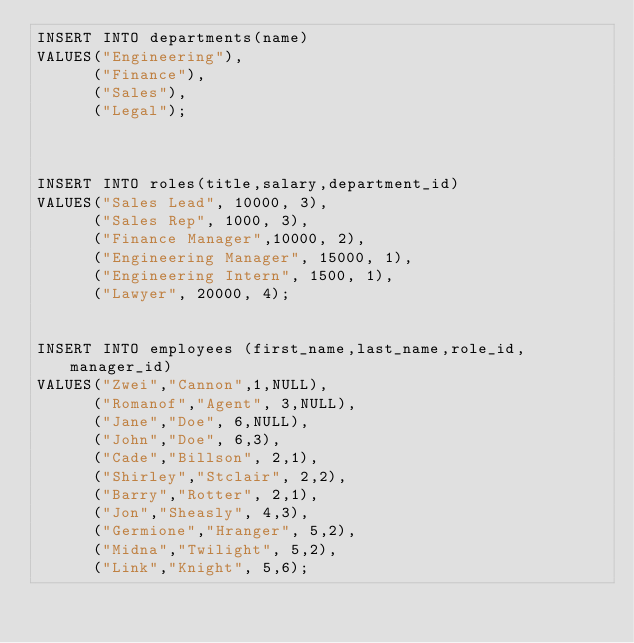Convert code to text. <code><loc_0><loc_0><loc_500><loc_500><_SQL_>INSERT INTO departments(name)
VALUES("Engineering"),
      ("Finance"),
      ("Sales"),
      ("Legal");



INSERT INTO roles(title,salary,department_id)
VALUES("Sales Lead", 10000, 3),
      ("Sales Rep", 1000, 3),
      ("Finance Manager",10000, 2),
      ("Engineering Manager", 15000, 1),
      ("Engineering Intern", 1500, 1),
      ("Lawyer", 20000, 4);


INSERT INTO employees (first_name,last_name,role_id,manager_id)
VALUES("Zwei","Cannon",1,NULL),
      ("Romanof","Agent", 3,NULL),
      ("Jane","Doe", 6,NULL),
      ("John","Doe", 6,3),
      ("Cade","Billson", 2,1),
      ("Shirley","Stclair", 2,2),
      ("Barry","Rotter", 2,1),
      ("Jon","Sheasly", 4,3),
      ("Germione","Hranger", 5,2),
      ("Midna","Twilight", 5,2),
      ("Link","Knight", 5,6);
</code> 